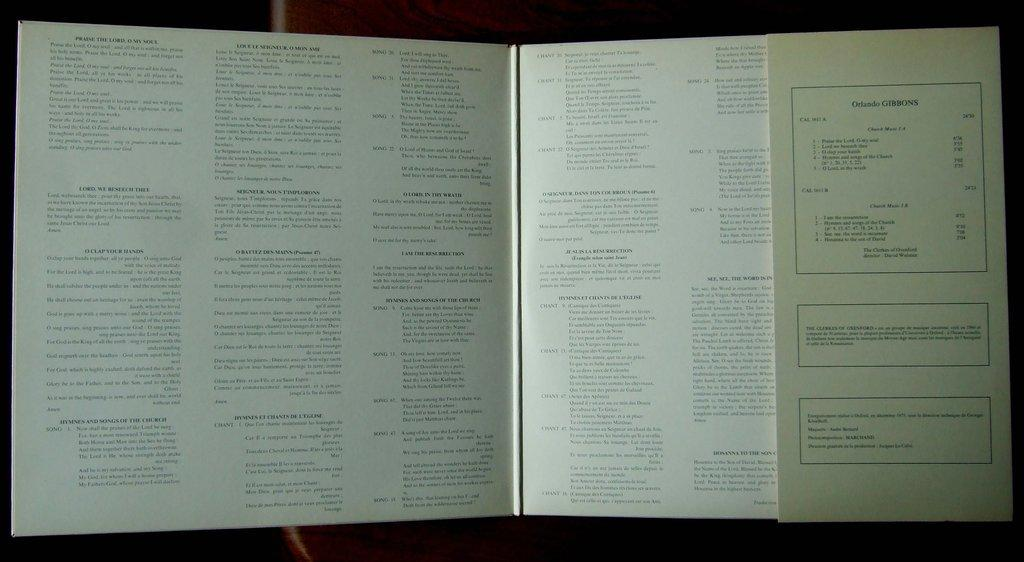<image>
Describe the image concisely. An opened book with the name Orlando Gibbons on it. 